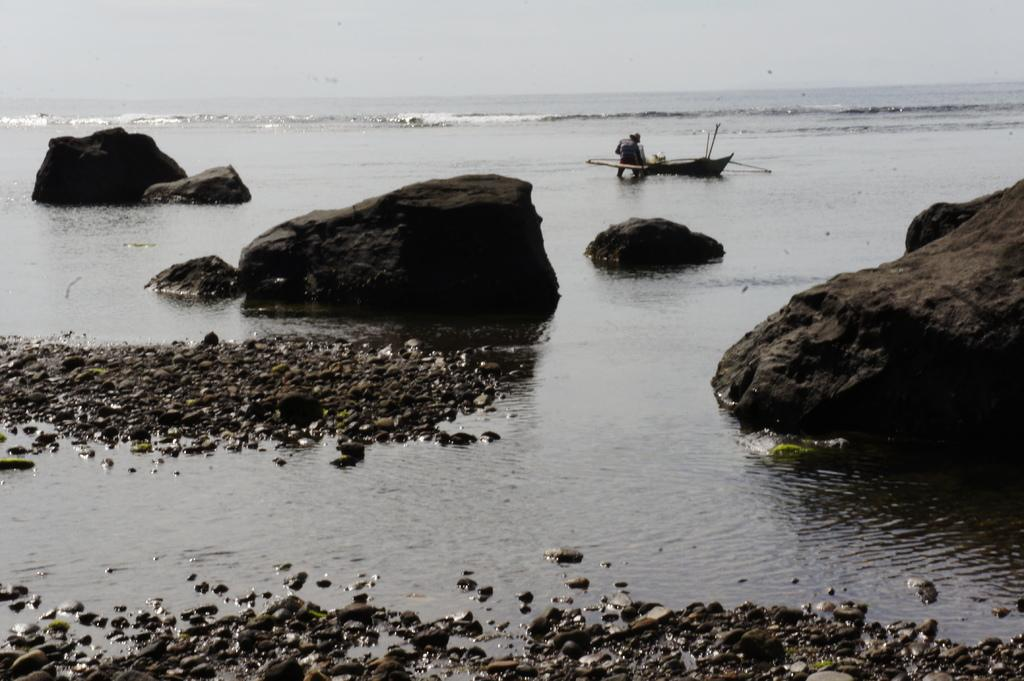What is the primary element visible in the image? There is water in the image. What can be found within the water? There are stones in the water. What other objects are present in the image? There are rocks in the image. Is there any man-made object on the water? Yes, there is a boat on the water. What type of zinc can be seen on the boat in the image? There is no zinc visible on the boat in the image. How does the sleet affect the water in the image? There is no mention of sleet in the image, so its effect cannot be determined. 